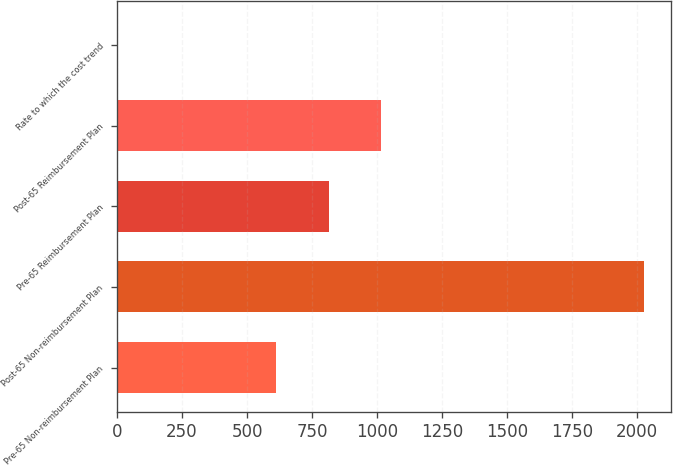Convert chart to OTSL. <chart><loc_0><loc_0><loc_500><loc_500><bar_chart><fcel>Pre-65 Non-reimbursement Plan<fcel>Post-65 Non-reimbursement Plan<fcel>Pre-65 Reimbursement Plan<fcel>Post-65 Reimbursement Plan<fcel>Rate to which the cost trend<nl><fcel>611.55<fcel>2028<fcel>813.9<fcel>1016.25<fcel>4.5<nl></chart> 